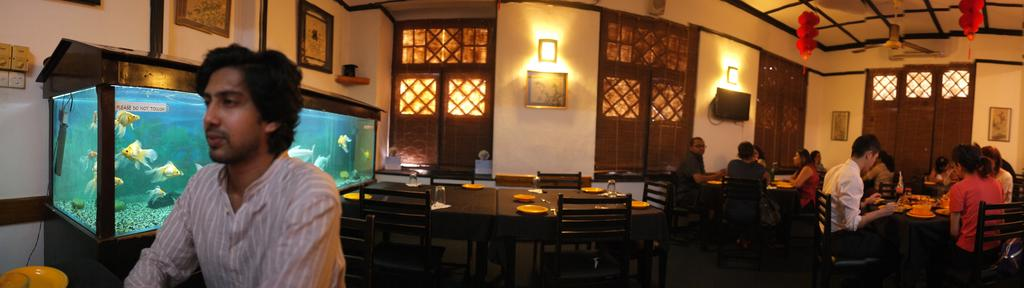Where was the image taken? The image was taken inside a restaurant. What are the people in the image doing? The people in the image are eating at tables. Are all the tables occupied in the image? No, there are unoccupied tables in the image. What can be seen to the left of the image? There is an aquarium to the left of the image. What type of quince is being served at the unoccupied tables in the image? There is no quince present in the image, as it only shows people eating at tables and an aquarium to the left. What attraction is visible in the image? The image does not depict any specific attraction; it is a scene inside a restaurant with people eating and an aquarium. 